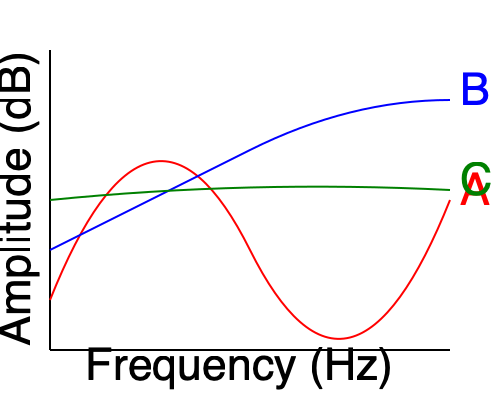As a DJ and audio equipment expert, you're comparing frequency response curves for different types of audio equipment. The graph shows three curves (A, B, and C) representing the frequency response of various audio devices. Which curve would most likely represent a subwoofer optimized for modern electronic music, and why? To answer this question, let's analyze each curve and consider the characteristics of a subwoofer optimized for modern electronic music:

1. Curve A (Red):
   - Shows a peak in the mid-range frequencies
   - Rolls off at both low and high frequencies
   - This curve is typical for a full-range speaker or monitor

2. Curve B (Blue):
   - Emphasizes high frequencies
   - Has a gradual roll-off in the low end
   - This curve resembles a tweeter or high-frequency driver

3. Curve C (Green):
   - Emphasizes low frequencies
   - Has a sharp roll-off in the mid to high frequencies
   - Maintains a relatively flat response in the bass range

A subwoofer optimized for modern electronic music should have the following characteristics:
- Strong emphasis on low frequencies (typically 20-200 Hz)
- Sharp roll-off in mid to high frequencies
- Relatively flat response in the bass range for accurate reproduction

Comparing these characteristics to the given curves, Curve C (Green) best matches the ideal frequency response for a subwoofer optimized for modern electronic music. It emphasizes the low frequencies while sharply attenuating higher frequencies, which is crucial for reproducing the deep bass and sub-bass elements common in electronic music genres.
Answer: Curve C (Green) 